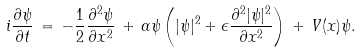<formula> <loc_0><loc_0><loc_500><loc_500>i \frac { \partial \psi } { \partial t } \, = \, - \frac { 1 } { 2 } \frac { \partial ^ { 2 } \psi } { \partial x ^ { 2 } } \, + \, \alpha \psi \left ( | \psi | ^ { 2 } + \epsilon \frac { \partial ^ { 2 } | \psi | ^ { 2 } } { \partial x ^ { 2 } } \right ) \, + \, V ( x ) \psi .</formula> 